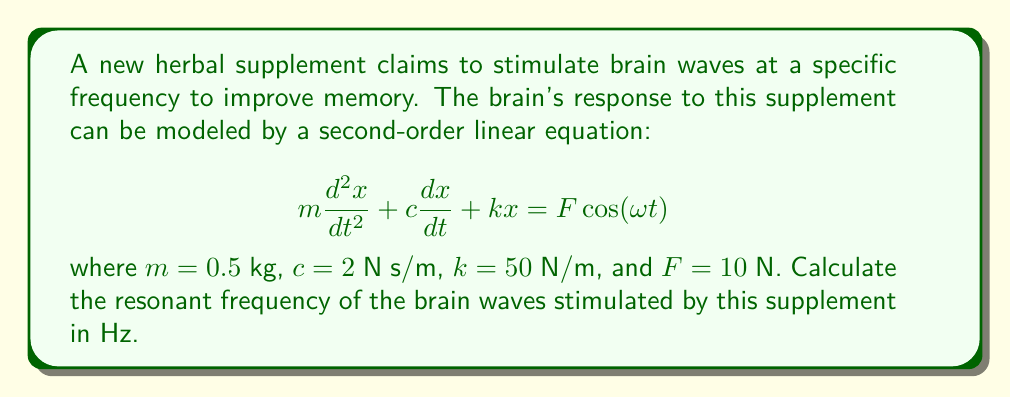Can you solve this math problem? To find the resonant frequency, we need to follow these steps:

1) The resonant frequency for a second-order linear system is given by the formula:

   $$\omega_n = \sqrt{\frac{k}{m}}$$

   where $\omega_n$ is the natural frequency in radians per second.

2) We are given:
   $k = 50$ N/m
   $m = 0.5$ kg

3) Substituting these values into the formula:

   $$\omega_n = \sqrt{\frac{50}{0.5}} = \sqrt{100} = 10\text{ rad/s}$$

4) However, we need the frequency in Hz. To convert from radians per second to Hz, we use the formula:

   $$f = \frac{\omega_n}{2\pi}$$

5) Substituting our value for $\omega_n$:

   $$f = \frac{10}{2\pi} \approx 1.59\text{ Hz}$$

Therefore, the resonant frequency of the brain waves stimulated by this herbal supplement is approximately 1.59 Hz.
Answer: 1.59 Hz 